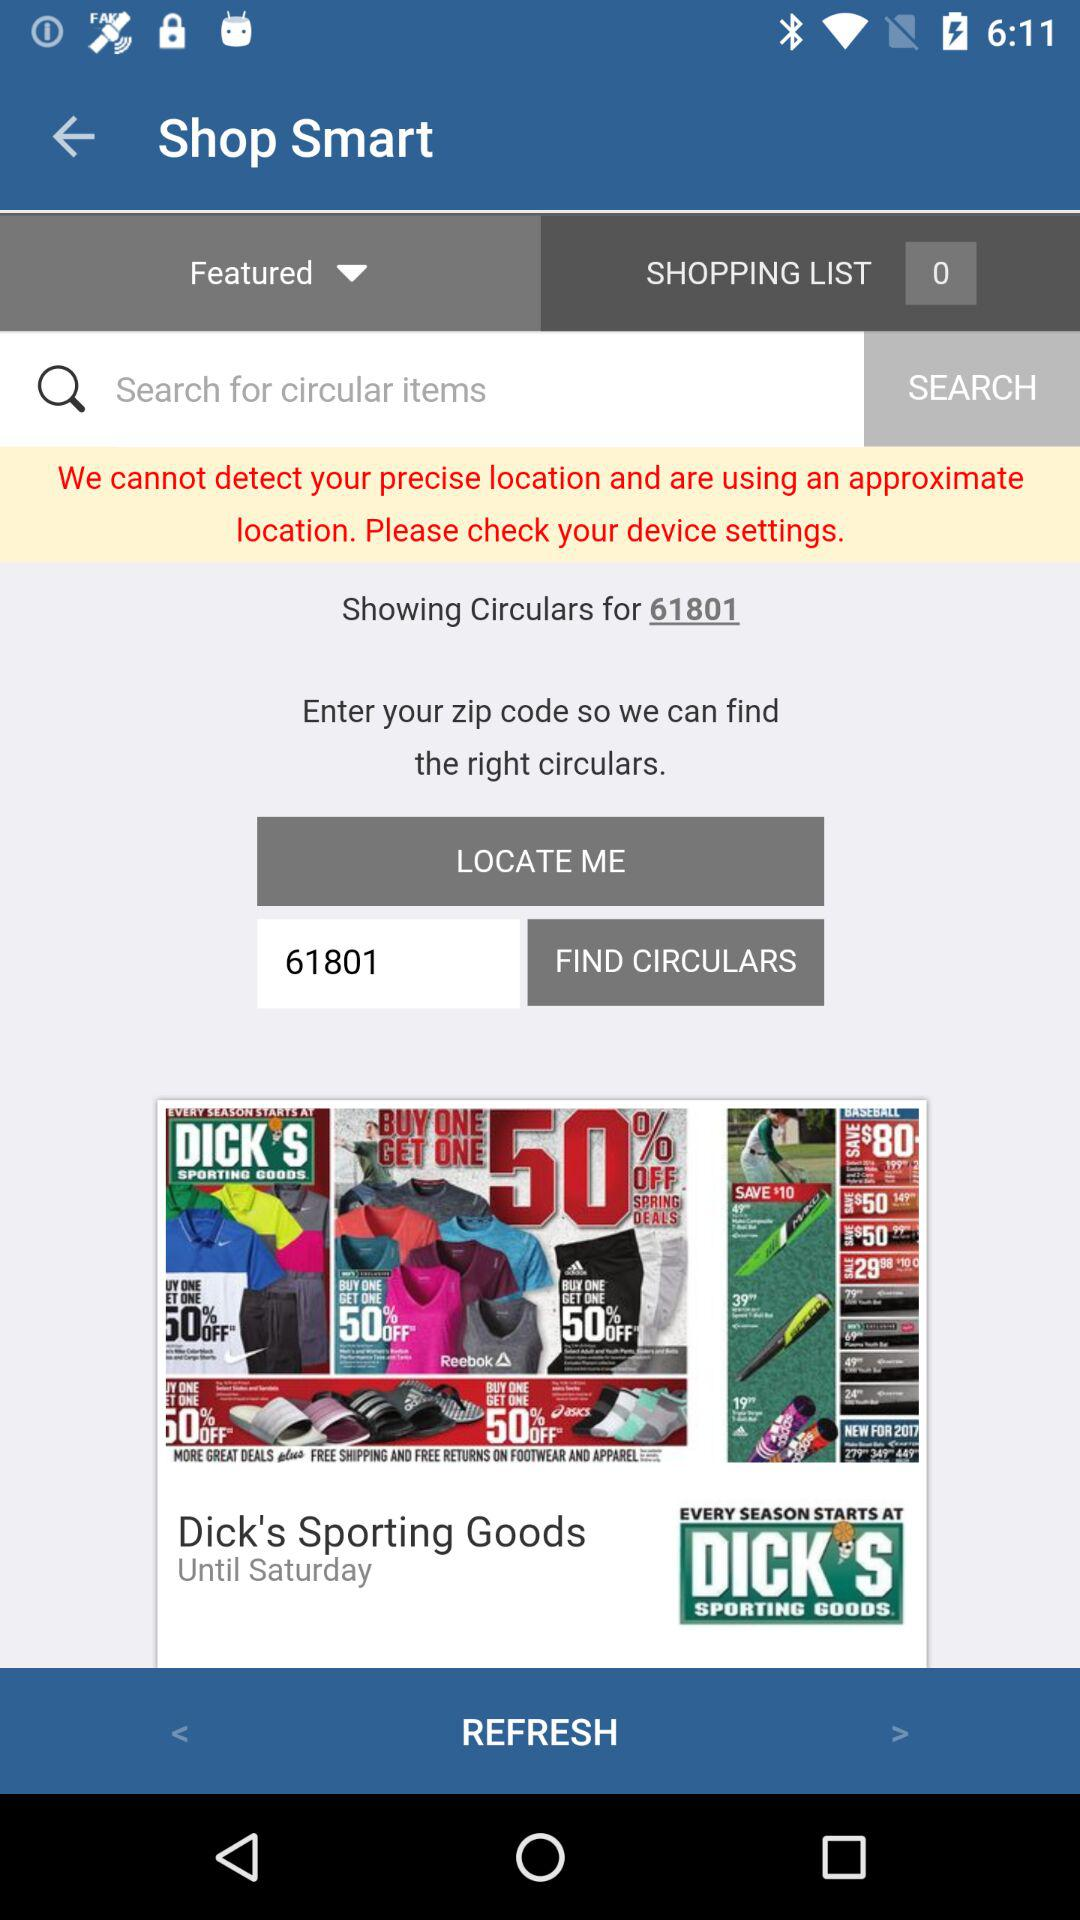Which tab is selected? The selected tab is "SHOPPING LIST 0". 